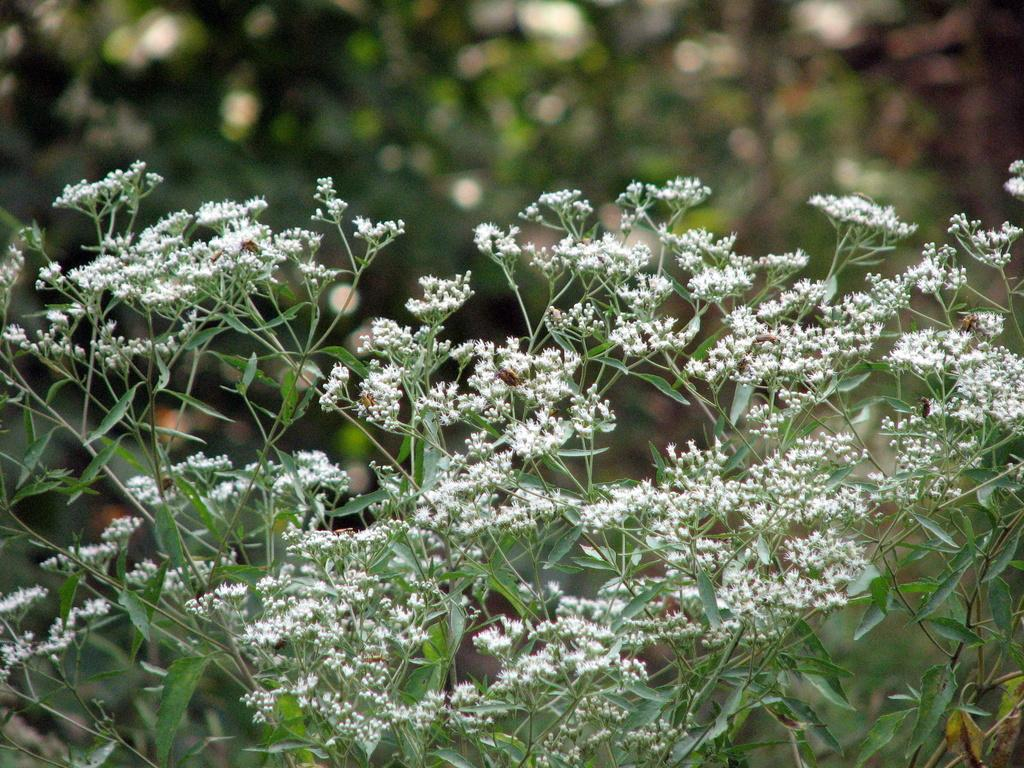What types of living organisms can be seen in the image? Plants and flowers are visible in the image. Can you describe the specific features of the plants in the image? The plants in the image have flowers, which are a part of the plant's reproductive system. How many pizzas are being served on the metal peace sign in the image? There are no pizzas or metal peace signs present in the image; it features plants and flowers. 